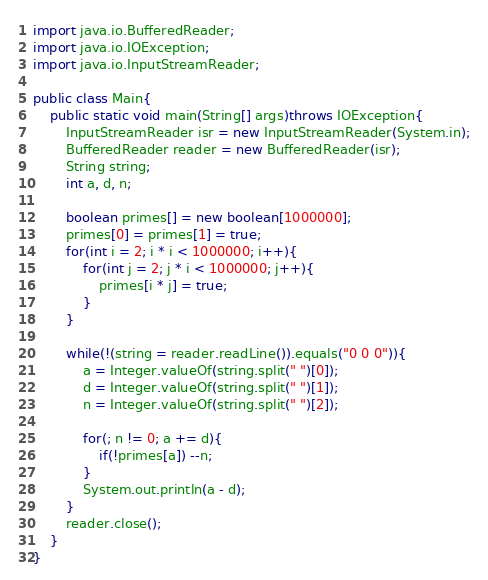Convert code to text. <code><loc_0><loc_0><loc_500><loc_500><_Java_>import java.io.BufferedReader;
import java.io.IOException;
import java.io.InputStreamReader;

public class Main{
	public static void main(String[] args)throws IOException{
		InputStreamReader isr = new InputStreamReader(System.in);
		BufferedReader reader = new BufferedReader(isr);
		String string;
		int a, d, n;
		
		boolean primes[] = new boolean[1000000];
		primes[0] = primes[1] = true;
		for(int i = 2; i * i < 1000000; i++){
			for(int j = 2; j * i < 1000000; j++){
				primes[i * j] = true;
			}
		}
		
		while(!(string = reader.readLine()).equals("0 0 0")){
			a = Integer.valueOf(string.split(" ")[0]);
			d = Integer.valueOf(string.split(" ")[1]);
			n = Integer.valueOf(string.split(" ")[2]);
			
			for(; n != 0; a += d){
				if(!primes[a]) --n;
			}
			System.out.println(a - d);
		}
		reader.close();
	}
}</code> 